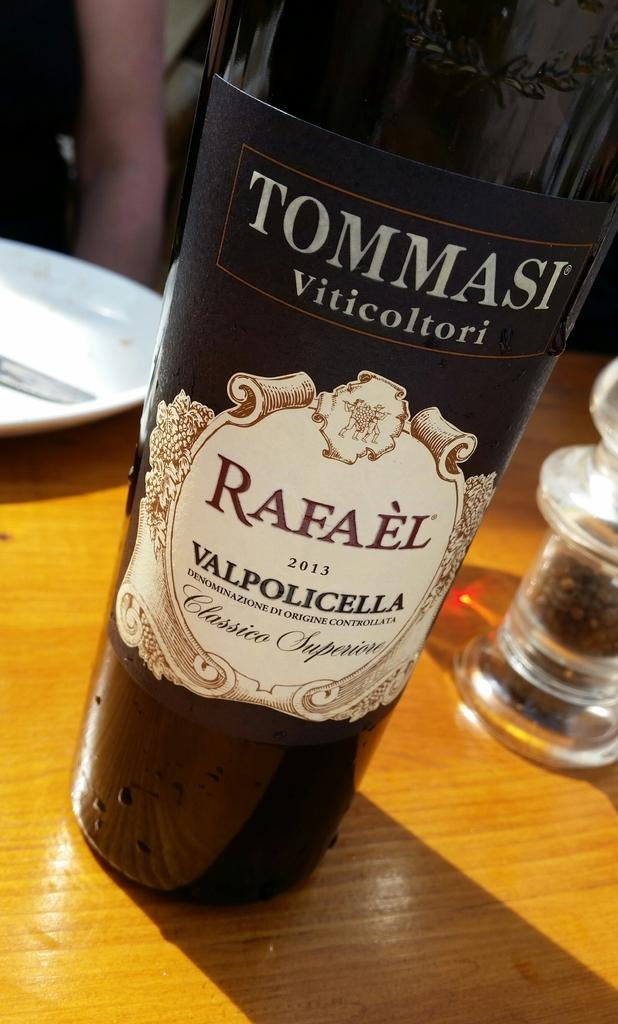<image>
Relay a brief, clear account of the picture shown. A bottle of Ommasi Viticoltori wine is on a table 